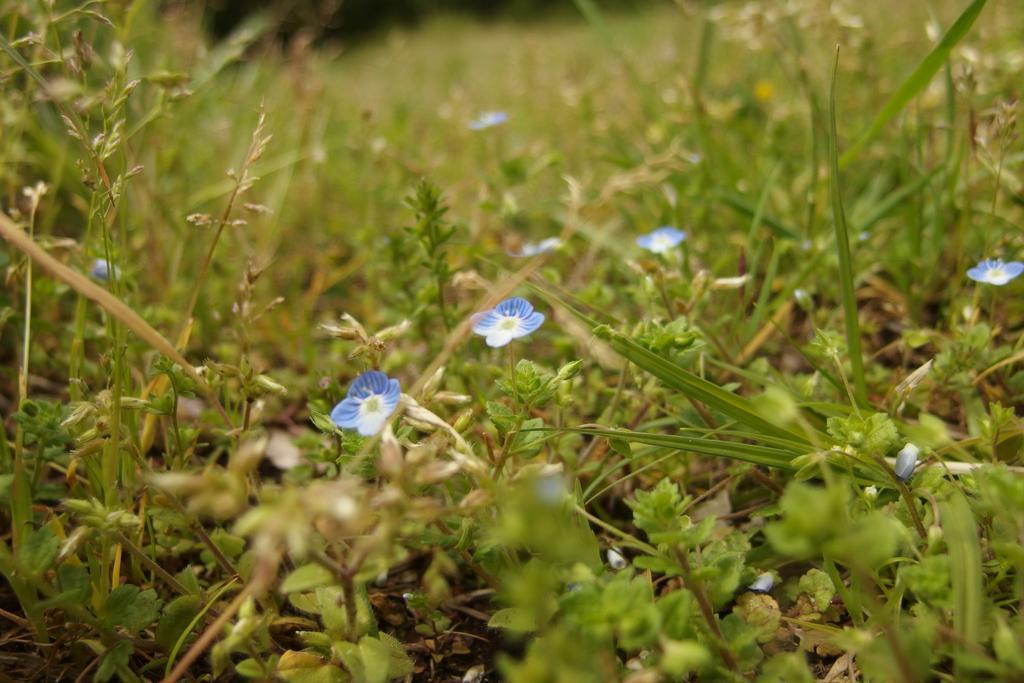Describe this image in one or two sentences. In this image we can see there are many plants, there are purple flowers. 